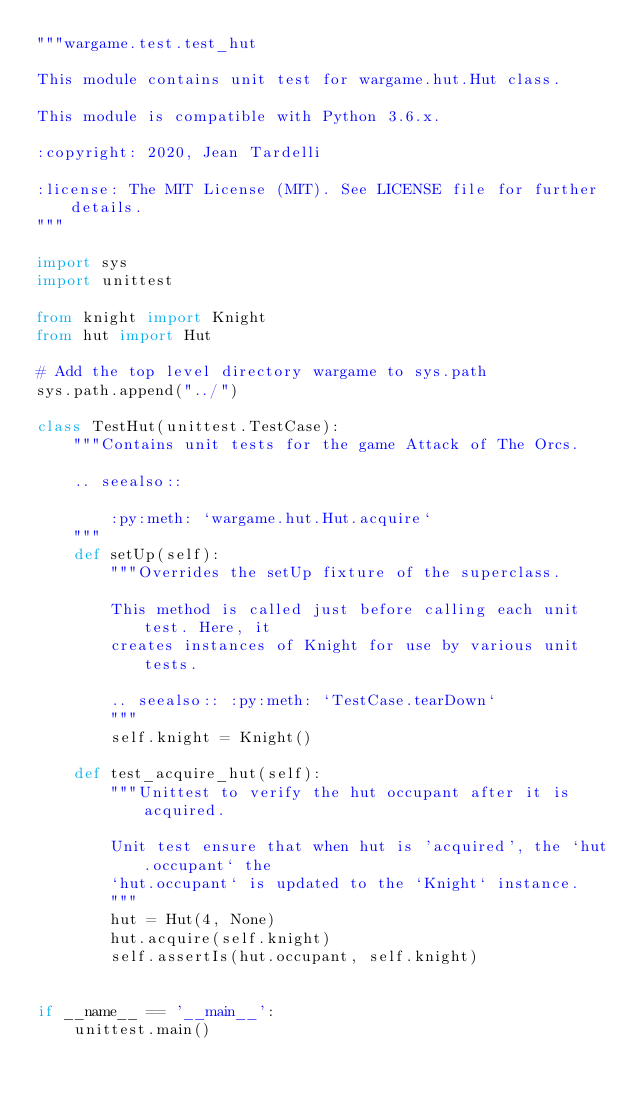<code> <loc_0><loc_0><loc_500><loc_500><_Python_>"""wargame.test.test_hut

This module contains unit test for wargame.hut.Hut class.

This module is compatible with Python 3.6.x.

:copyright: 2020, Jean Tardelli

:license: The MIT License (MIT). See LICENSE file for further details.
"""

import sys
import unittest

from knight import Knight
from hut import Hut

# Add the top level directory wargame to sys.path
sys.path.append("../")

class TestHut(unittest.TestCase):
    """Contains unit tests for the game Attack of The Orcs.

    .. seealso::

        :py:meth: `wargame.hut.Hut.acquire`
    """
    def setUp(self):
        """Overrides the setUp fixture of the superclass.

        This method is called just before calling each unit test. Here, it
        creates instances of Knight for use by various unit tests.

        .. seealso:: :py:meth: `TestCase.tearDown`
        """
        self.knight = Knight()

    def test_acquire_hut(self):
        """Unittest to verify the hut occupant after it is acquired.

        Unit test ensure that when hut is 'acquired', the `hut.occupant` the
        `hut.occupant` is updated to the `Knight` instance.
        """
        hut = Hut(4, None)
        hut.acquire(self.knight)
        self.assertIs(hut.occupant, self.knight)


if __name__ == '__main__':
    unittest.main()
</code> 